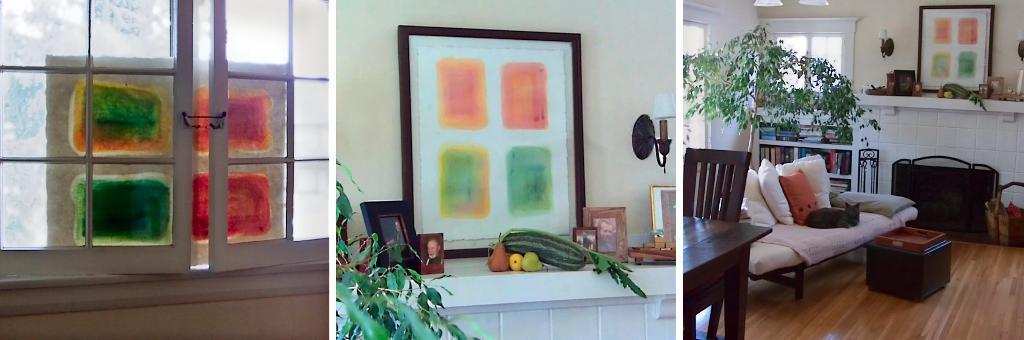Please provide a concise description of this image. In this picture we can see windows, photo frames and vegetables, And also we can see sofa, books and a plant. 